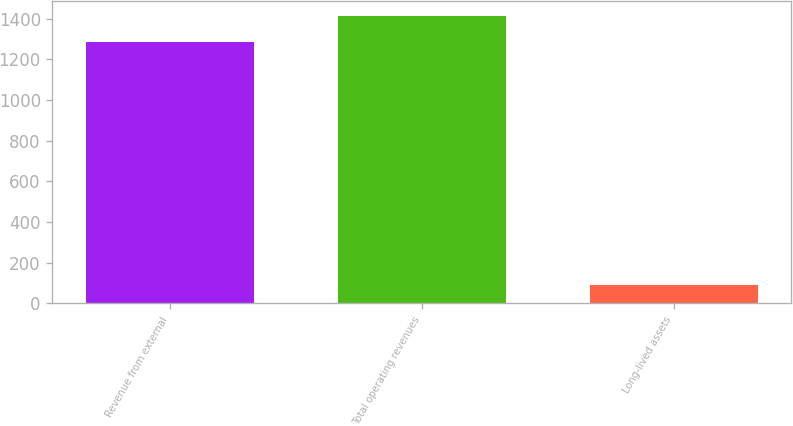Convert chart. <chart><loc_0><loc_0><loc_500><loc_500><bar_chart><fcel>Revenue from external<fcel>Total operating revenues<fcel>Long-lived assets<nl><fcel>1286.7<fcel>1414.99<fcel>91.6<nl></chart> 